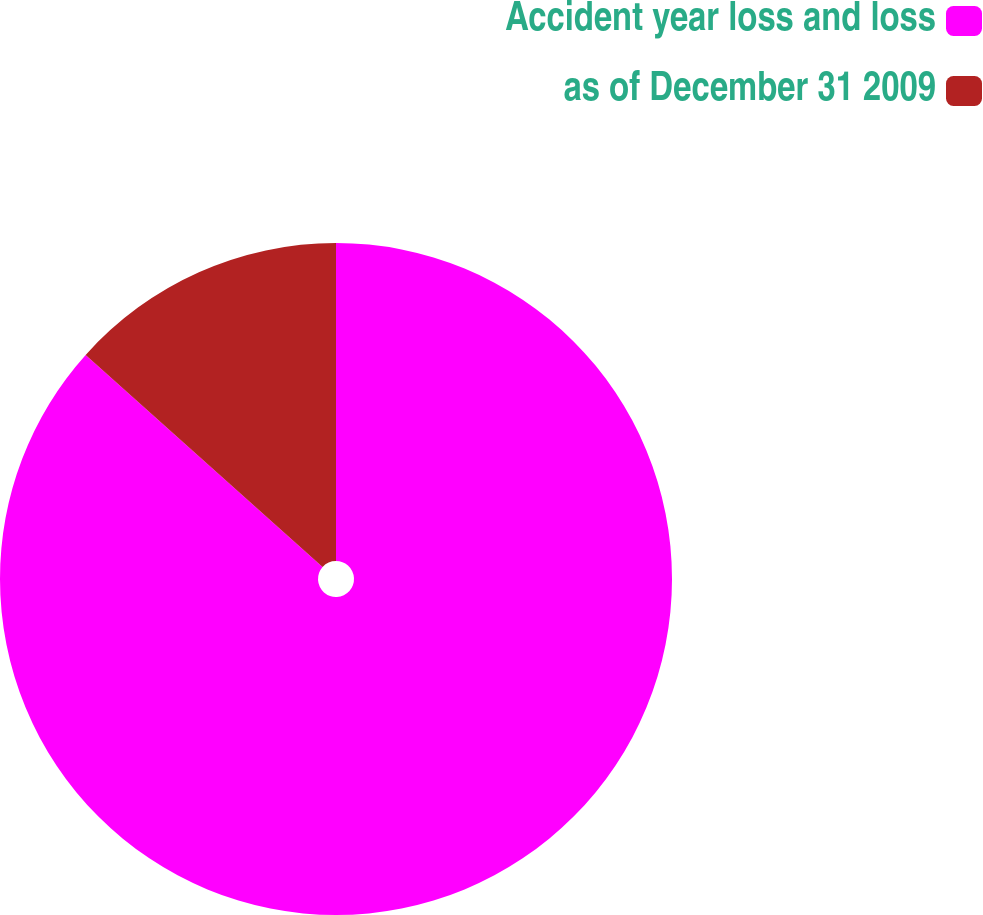Convert chart. <chart><loc_0><loc_0><loc_500><loc_500><pie_chart><fcel>Accident year loss and loss<fcel>as of December 31 2009<nl><fcel>86.62%<fcel>13.38%<nl></chart> 